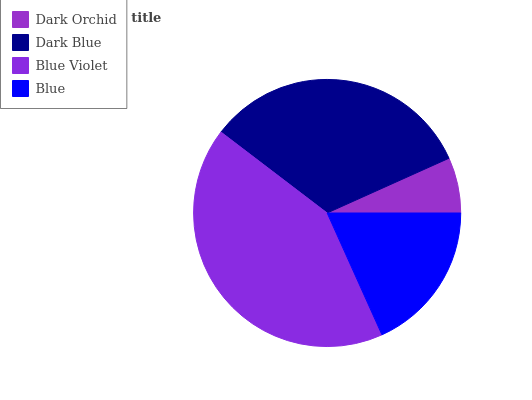Is Dark Orchid the minimum?
Answer yes or no. Yes. Is Blue Violet the maximum?
Answer yes or no. Yes. Is Dark Blue the minimum?
Answer yes or no. No. Is Dark Blue the maximum?
Answer yes or no. No. Is Dark Blue greater than Dark Orchid?
Answer yes or no. Yes. Is Dark Orchid less than Dark Blue?
Answer yes or no. Yes. Is Dark Orchid greater than Dark Blue?
Answer yes or no. No. Is Dark Blue less than Dark Orchid?
Answer yes or no. No. Is Dark Blue the high median?
Answer yes or no. Yes. Is Blue the low median?
Answer yes or no. Yes. Is Dark Orchid the high median?
Answer yes or no. No. Is Dark Orchid the low median?
Answer yes or no. No. 